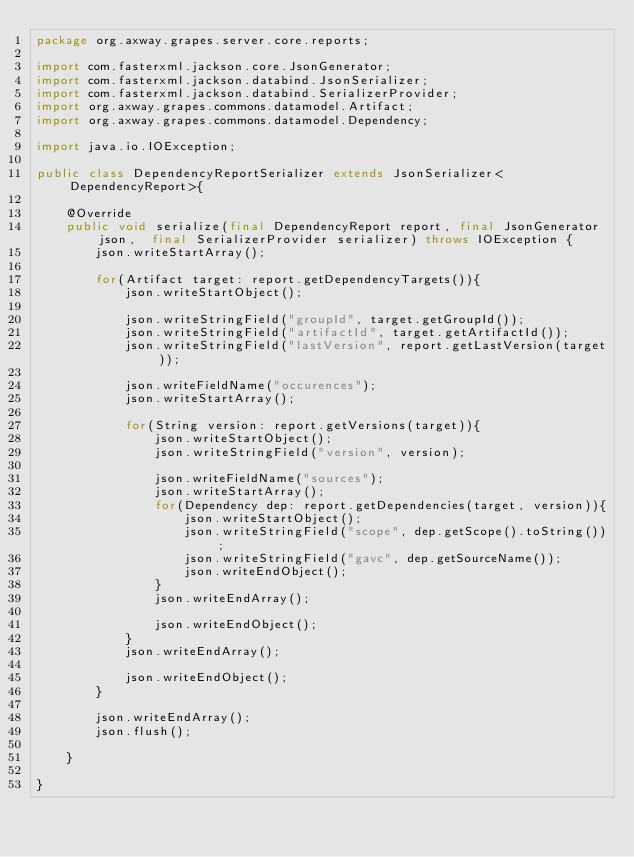<code> <loc_0><loc_0><loc_500><loc_500><_Java_>package org.axway.grapes.server.core.reports;

import com.fasterxml.jackson.core.JsonGenerator;
import com.fasterxml.jackson.databind.JsonSerializer;
import com.fasterxml.jackson.databind.SerializerProvider;
import org.axway.grapes.commons.datamodel.Artifact;
import org.axway.grapes.commons.datamodel.Dependency;

import java.io.IOException;

public class DependencyReportSerializer extends JsonSerializer<DependencyReport>{

    @Override
    public void serialize(final DependencyReport report, final JsonGenerator json,	final SerializerProvider serializer) throws IOException {
        json.writeStartArray();

        for(Artifact target: report.getDependencyTargets()){
            json.writeStartObject();

            json.writeStringField("groupId", target.getGroupId());
            json.writeStringField("artifactId", target.getArtifactId());
            json.writeStringField("lastVersion", report.getLastVersion(target));

            json.writeFieldName("occurences");
            json.writeStartArray();

            for(String version: report.getVersions(target)){
                json.writeStartObject();
                json.writeStringField("version", version);

                json.writeFieldName("sources");
                json.writeStartArray();
                for(Dependency dep: report.getDependencies(target, version)){
                    json.writeStartObject();
                    json.writeStringField("scope", dep.getScope().toString());
                    json.writeStringField("gavc", dep.getSourceName());
                    json.writeEndObject();
                }
                json.writeEndArray();

                json.writeEndObject();
            }
            json.writeEndArray();

            json.writeEndObject();
        }

        json.writeEndArray();
        json.flush();

    }

}

</code> 